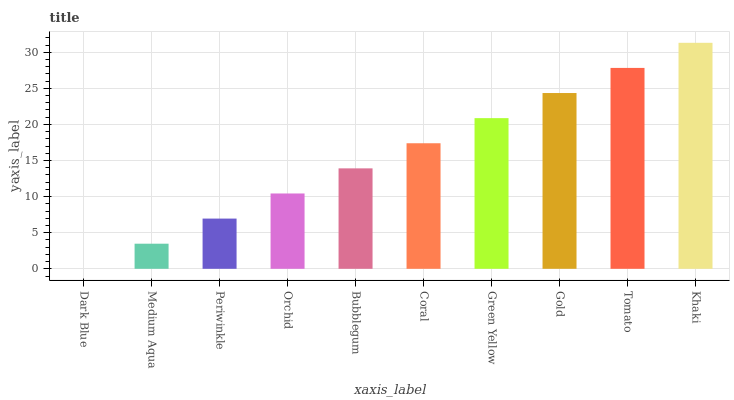Is Dark Blue the minimum?
Answer yes or no. Yes. Is Khaki the maximum?
Answer yes or no. Yes. Is Medium Aqua the minimum?
Answer yes or no. No. Is Medium Aqua the maximum?
Answer yes or no. No. Is Medium Aqua greater than Dark Blue?
Answer yes or no. Yes. Is Dark Blue less than Medium Aqua?
Answer yes or no. Yes. Is Dark Blue greater than Medium Aqua?
Answer yes or no. No. Is Medium Aqua less than Dark Blue?
Answer yes or no. No. Is Coral the high median?
Answer yes or no. Yes. Is Bubblegum the low median?
Answer yes or no. Yes. Is Orchid the high median?
Answer yes or no. No. Is Medium Aqua the low median?
Answer yes or no. No. 